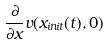<formula> <loc_0><loc_0><loc_500><loc_500>\frac { \partial } { \partial x } v ( x _ { i n i t } ( t ) , 0 )</formula> 